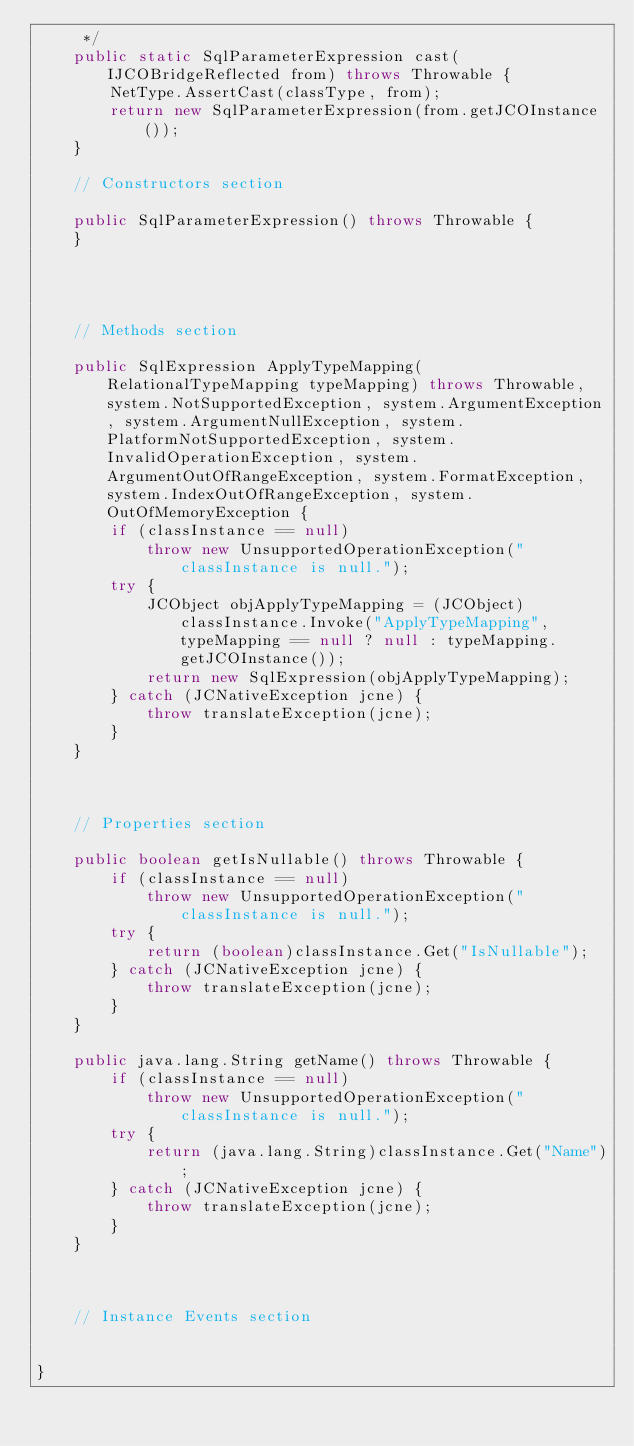Convert code to text. <code><loc_0><loc_0><loc_500><loc_500><_Java_>     */
    public static SqlParameterExpression cast(IJCOBridgeReflected from) throws Throwable {
        NetType.AssertCast(classType, from);
        return new SqlParameterExpression(from.getJCOInstance());
    }

    // Constructors section
    
    public SqlParameterExpression() throws Throwable {
    }



    
    // Methods section
    
    public SqlExpression ApplyTypeMapping(RelationalTypeMapping typeMapping) throws Throwable, system.NotSupportedException, system.ArgumentException, system.ArgumentNullException, system.PlatformNotSupportedException, system.InvalidOperationException, system.ArgumentOutOfRangeException, system.FormatException, system.IndexOutOfRangeException, system.OutOfMemoryException {
        if (classInstance == null)
            throw new UnsupportedOperationException("classInstance is null.");
        try {
            JCObject objApplyTypeMapping = (JCObject)classInstance.Invoke("ApplyTypeMapping", typeMapping == null ? null : typeMapping.getJCOInstance());
            return new SqlExpression(objApplyTypeMapping);
        } catch (JCNativeException jcne) {
            throw translateException(jcne);
        }
    }


    
    // Properties section
    
    public boolean getIsNullable() throws Throwable {
        if (classInstance == null)
            throw new UnsupportedOperationException("classInstance is null.");
        try {
            return (boolean)classInstance.Get("IsNullable");
        } catch (JCNativeException jcne) {
            throw translateException(jcne);
        }
    }

    public java.lang.String getName() throws Throwable {
        if (classInstance == null)
            throw new UnsupportedOperationException("classInstance is null.");
        try {
            return (java.lang.String)classInstance.Get("Name");
        } catch (JCNativeException jcne) {
            throw translateException(jcne);
        }
    }



    // Instance Events section
    

}</code> 